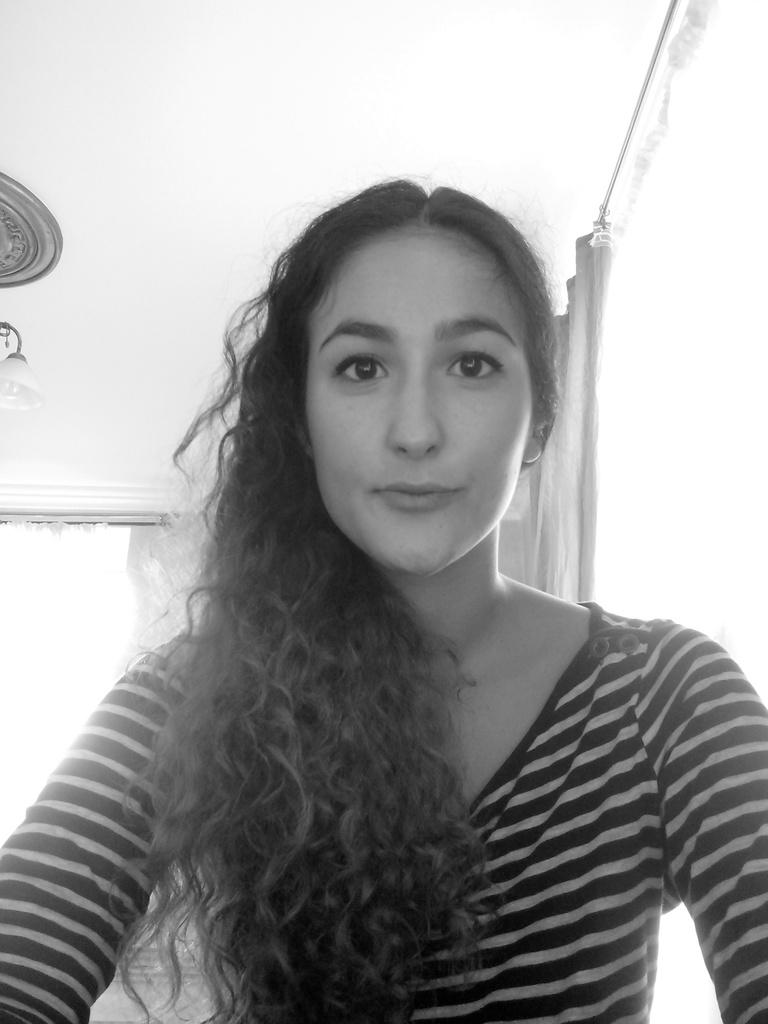What is the color scheme of the image? The image is black and white. Who is present in the image? There is a girl in the image. What can be seen in the background of the image? There is a curtain, windows, and a light on the ceiling in the background of the image. What type of quiver is the girl holding in the image? There is no quiver present in the image; it is a black and white image of a girl with a background containing a curtain, windows, and a light on the ceiling. 